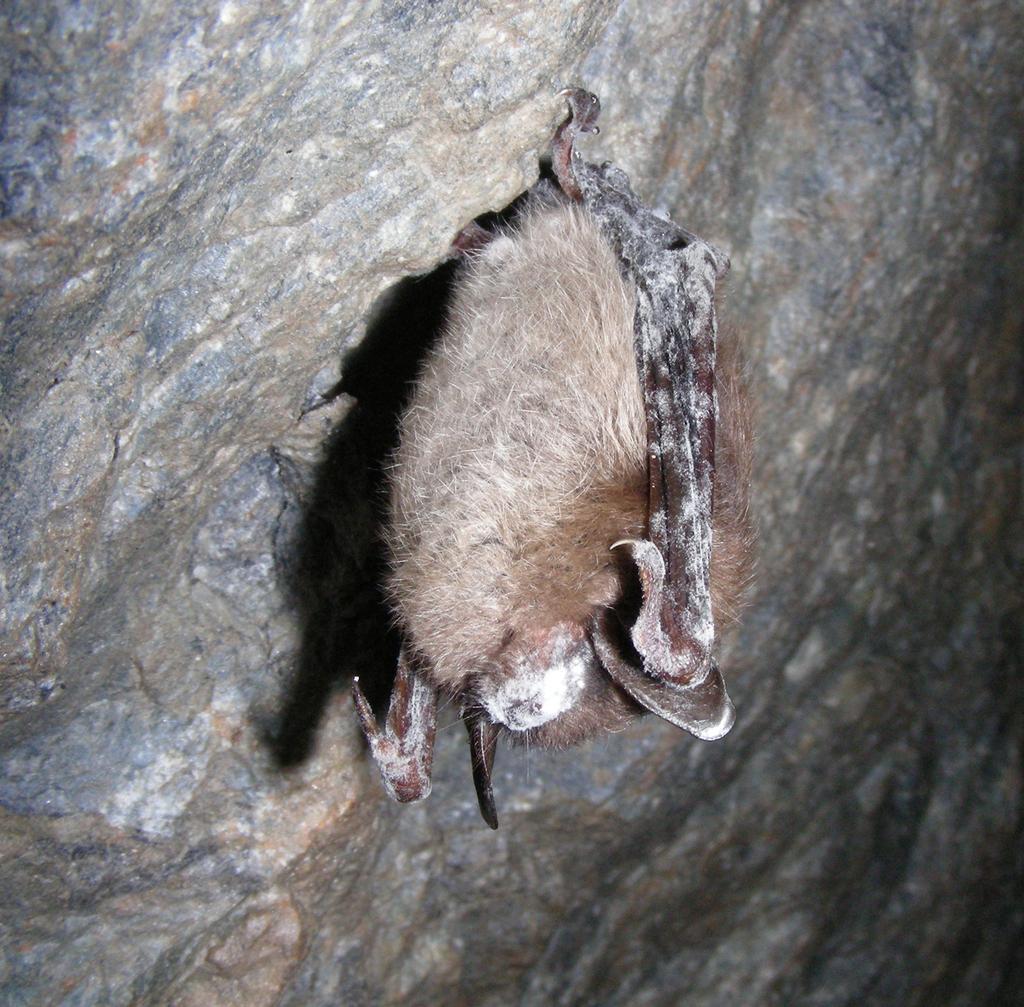Could you give a brief overview of what you see in this image? This picture is clicked outside. In the center of this image we can see a bat like thing seems to be hanging on the rock. 